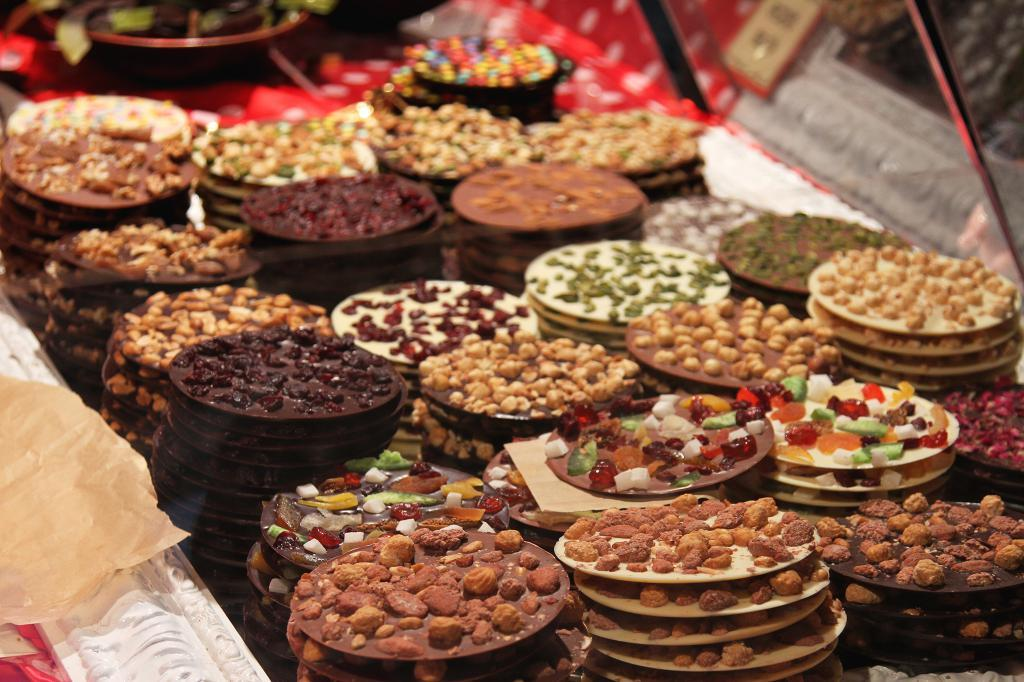What is placed on the table in the image? There are food items placed on a table in the image. Can you describe the colors of the food items? The food items have brown, maroon, orange, and white colors. What is located on the right side of the image? There are mirrors on the right side of the image. What type of bottle can be seen in the image? There is no bottle present in the image. What is the desire of the food items in the image? Food items do not have desires, as they are inanimate objects. 